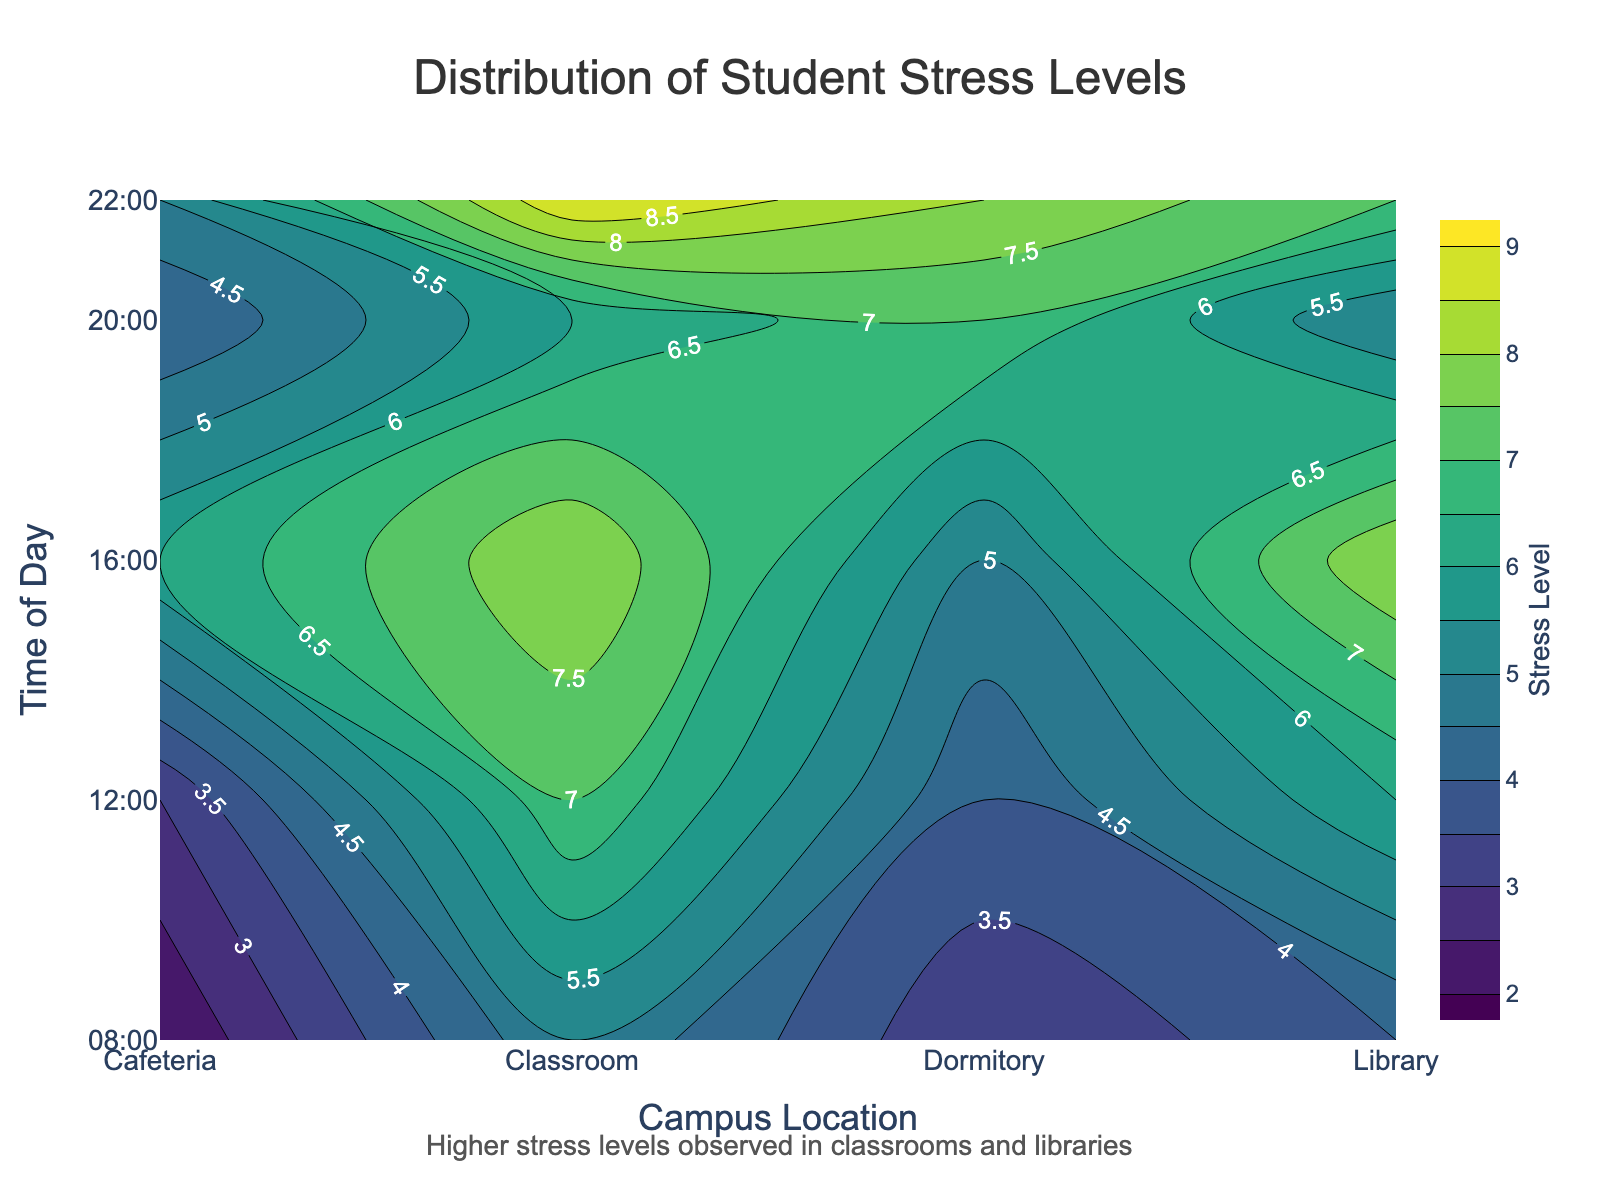What is the title of the plot? The title of the plot is usually placed at the top and provides a summary of the graphical content. In this case, it reads "Distribution of Student Stress Levels".
Answer: Distribution of Student Stress Levels What are the labels of the x-axis and y-axis? The labels along the x-axis pertain to the different campus locations, while the y-axis labels reflect times of day when stress levels were measured. The x-axis label is "Campus Location" and the y-axis label is "Time of Day".
Answer: Campus Location, Time of Day At what time of day do students experience the highest stress levels in the classroom? Observing the contour plot, the highest stress level in the classroom is indicated by the darkest color at 22:00. The annotation also hints at high stress in classrooms.
Answer: 22:00 How does the stress level at the library at 16:00 compare with that at 08:00? By comparing the color guidance related to stress levels (color scale) across the library row, darker hues indicate higher stress levels. The stress level at 16:00 (a darker shade) is significantly higher than at 08:00 (a lighter shade).
Answer: Higher at 16:00 Which campus location shows the most consistent stress levels throughout the day? Examining the contour plot, consistency can be inferred from uniform color shades across different times for a particular location. The cafeteria location exhibits similar stress levels indicated by more uniform shading across different times.
Answer: Cafeteria What is the average stress level in the dormitory across all listed times? To find the average, identify the stress levels at the dormitory location and compute their mean: (3+4+5+7+8)/5 = 27/5 = 5.4.
Answer: 5.4 Which time slot shows a significant increase in stress levels from the previous time slot in the classroom? Compare consecutive times in the classroom row. From 20:00 to 22:00, the stress level jumps significantly from 6 to 9.
Answer: 22:00 In which location is the lowest stress level observed and at what time? The contour plot indicates stress levels with lighter colors signaling lower stress. The cafeteria at 08:00 shows the lightest color corresponding to stress level 2.
Answer: Cafeteria at 08:00 Considering the color scale, between 12:00 and 16:00 at which campus location does the stress level show the greatest increase? By examining the differences in shading between 12:00 and 16:00 for all locations, the classroom shows the greatest change in color intensity from 7 to 8.
Answer: Classroom 